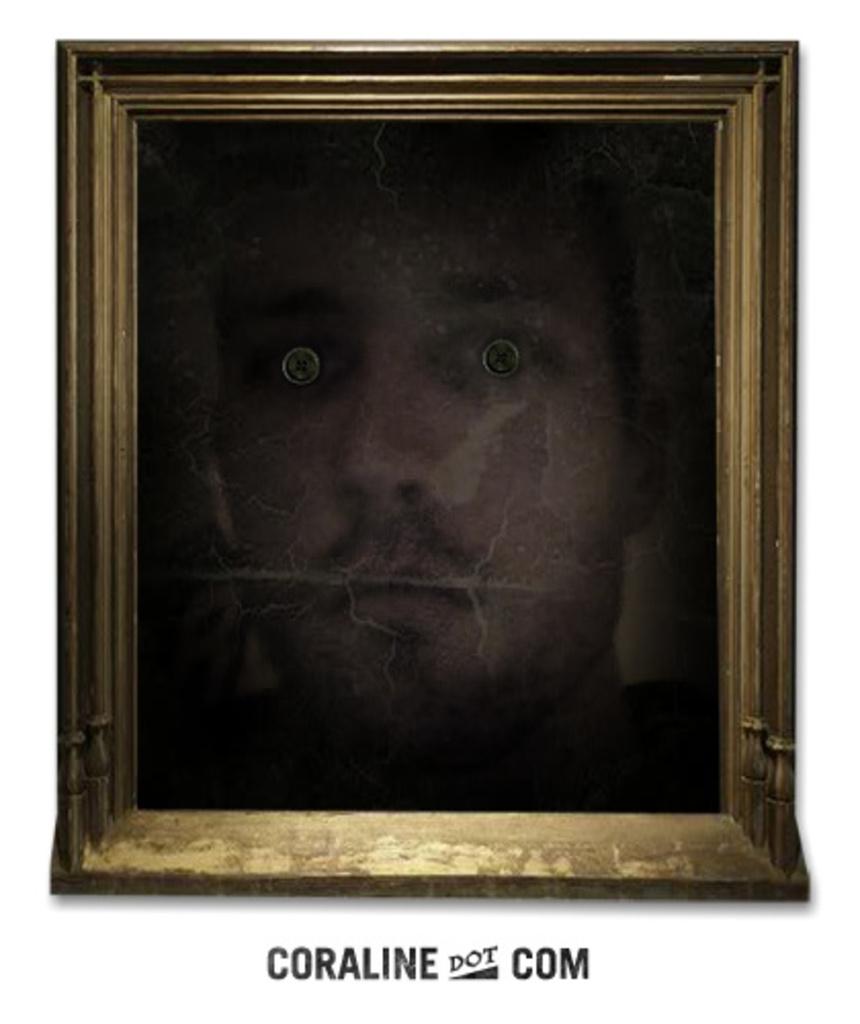Does coraline dot com take photos and turn them into canvas?
Provide a short and direct response. Unanswerable. 